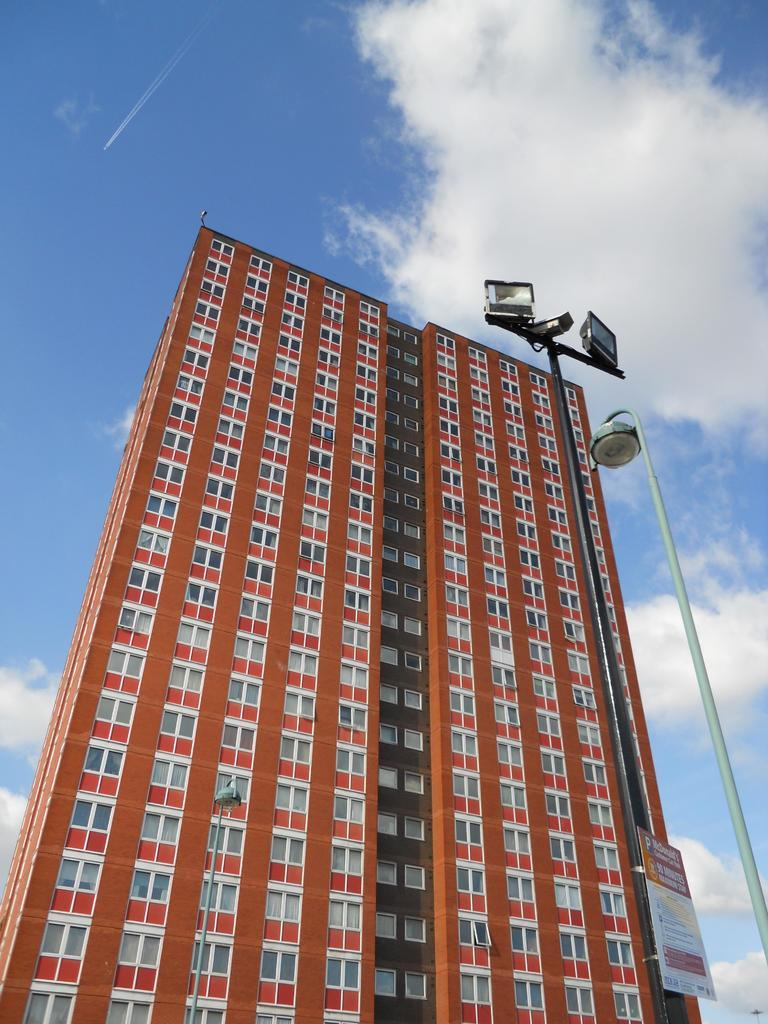What is the main structure in the center of the image? There is a building in the center of the image. What is located in front of the building? There is a pole in front of the building. What is attached to the pole? A banner with text is present on the pole. How would you describe the sky in the image? The sky is cloudy. What type of song is being played by the crook near the hydrant in the image? There is no crook or hydrant present in the image, and therefore no such activity can be observed. 